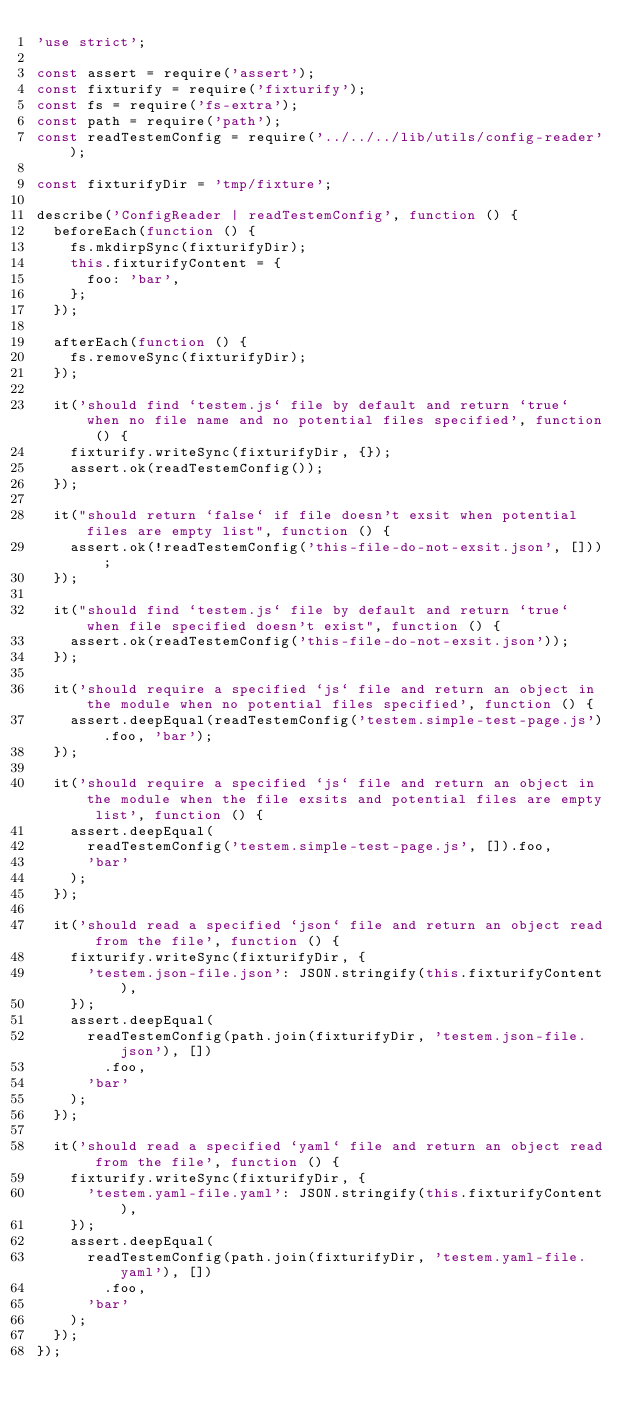<code> <loc_0><loc_0><loc_500><loc_500><_JavaScript_>'use strict';

const assert = require('assert');
const fixturify = require('fixturify');
const fs = require('fs-extra');
const path = require('path');
const readTestemConfig = require('../../../lib/utils/config-reader');

const fixturifyDir = 'tmp/fixture';

describe('ConfigReader | readTestemConfig', function () {
  beforeEach(function () {
    fs.mkdirpSync(fixturifyDir);
    this.fixturifyContent = {
      foo: 'bar',
    };
  });

  afterEach(function () {
    fs.removeSync(fixturifyDir);
  });

  it('should find `testem.js` file by default and return `true` when no file name and no potential files specified', function () {
    fixturify.writeSync(fixturifyDir, {});
    assert.ok(readTestemConfig());
  });

  it("should return `false` if file doesn't exsit when potential files are empty list", function () {
    assert.ok(!readTestemConfig('this-file-do-not-exsit.json', []));
  });

  it("should find `testem.js` file by default and return `true` when file specified doesn't exist", function () {
    assert.ok(readTestemConfig('this-file-do-not-exsit.json'));
  });

  it('should require a specified `js` file and return an object in the module when no potential files specified', function () {
    assert.deepEqual(readTestemConfig('testem.simple-test-page.js').foo, 'bar');
  });

  it('should require a specified `js` file and return an object in the module when the file exsits and potential files are empty list', function () {
    assert.deepEqual(
      readTestemConfig('testem.simple-test-page.js', []).foo,
      'bar'
    );
  });

  it('should read a specified `json` file and return an object read from the file', function () {
    fixturify.writeSync(fixturifyDir, {
      'testem.json-file.json': JSON.stringify(this.fixturifyContent),
    });
    assert.deepEqual(
      readTestemConfig(path.join(fixturifyDir, 'testem.json-file.json'), [])
        .foo,
      'bar'
    );
  });

  it('should read a specified `yaml` file and return an object read from the file', function () {
    fixturify.writeSync(fixturifyDir, {
      'testem.yaml-file.yaml': JSON.stringify(this.fixturifyContent),
    });
    assert.deepEqual(
      readTestemConfig(path.join(fixturifyDir, 'testem.yaml-file.yaml'), [])
        .foo,
      'bar'
    );
  });
});
</code> 